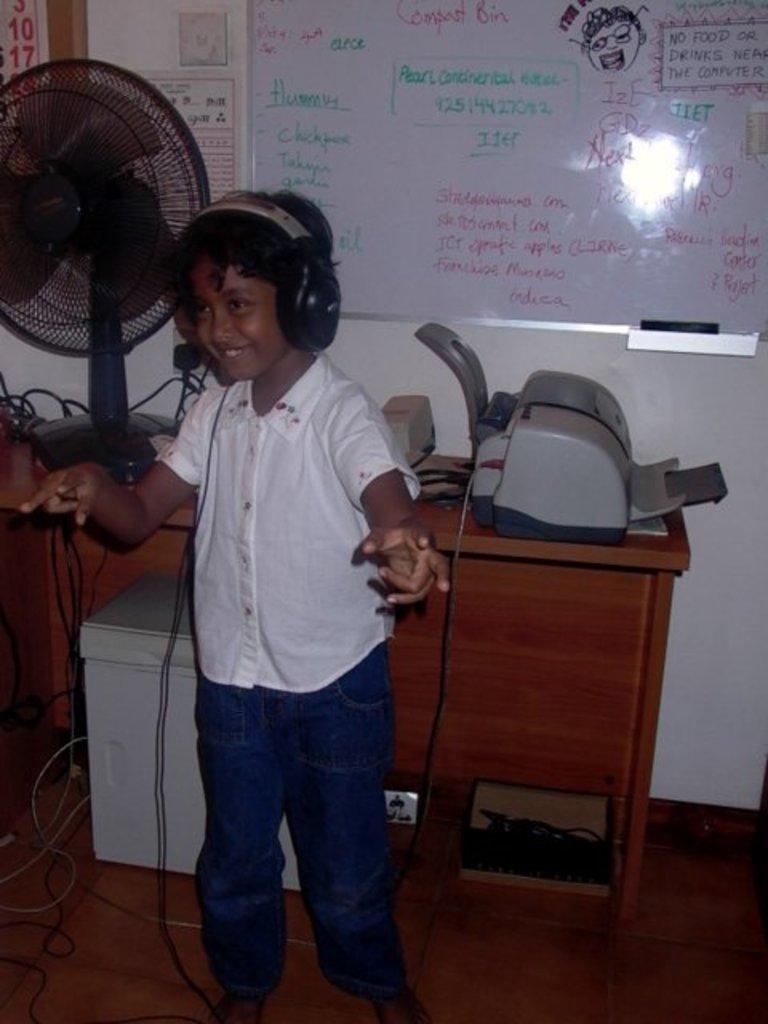Please provide a concise description of this image. In this picture we can see a boy smiling and wearing a headset. in the background we can see a board and a printer. 